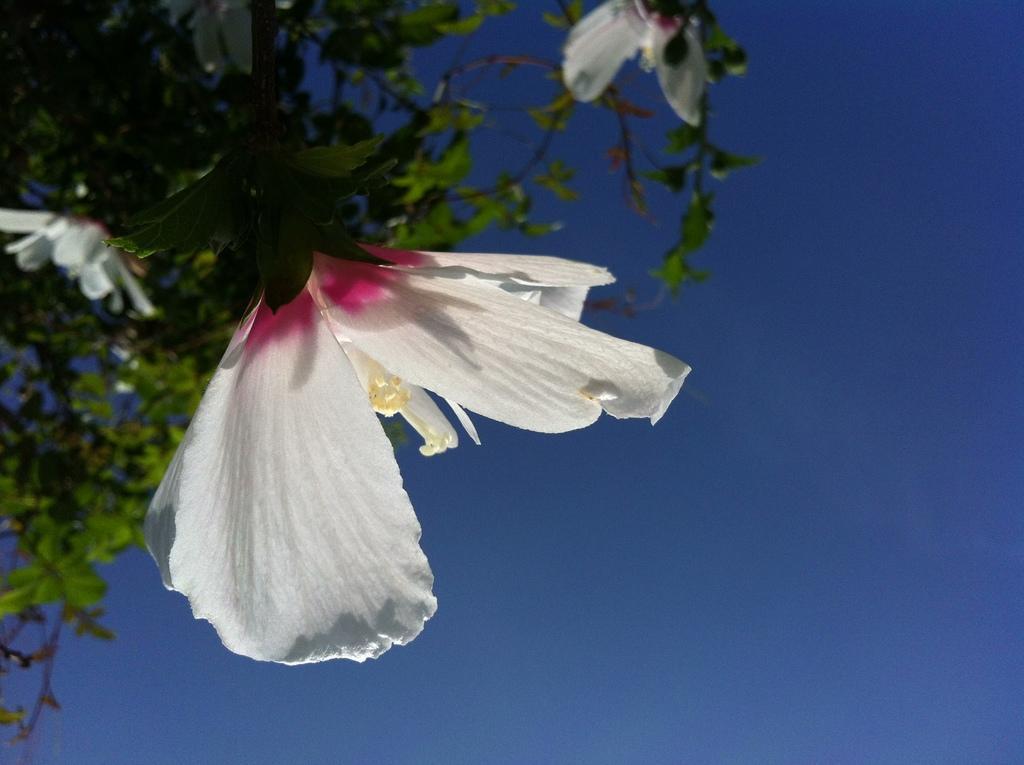Please provide a concise description of this image. In this image, we can see a tree with flowers and in the background, there is sky. 